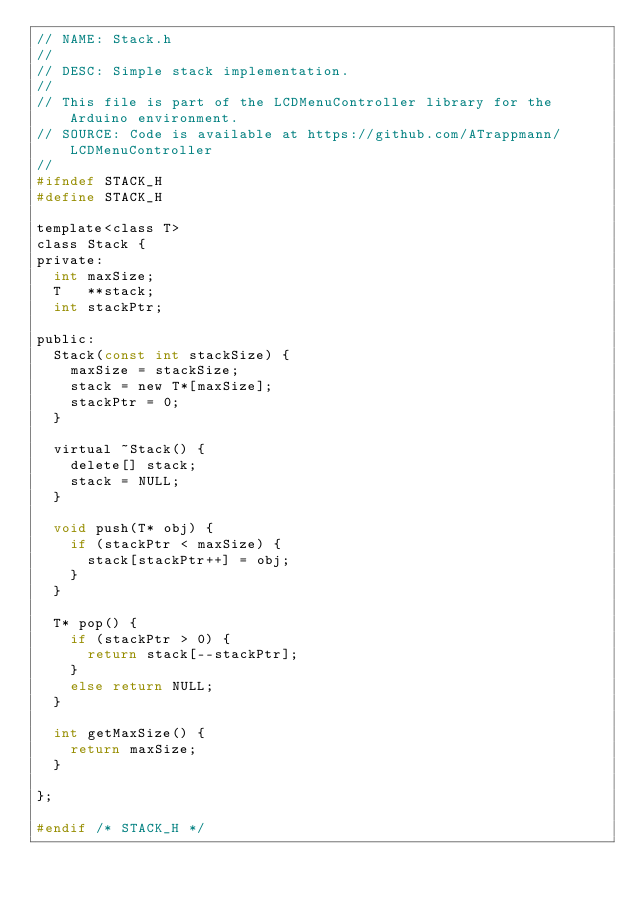Convert code to text. <code><loc_0><loc_0><loc_500><loc_500><_C_>// NAME: Stack.h
// 
// DESC: Simple stack implementation.
//
// This file is part of the LCDMenuController library for the Arduino environment.
// SOURCE: Code is available at https://github.com/ATrappmann/LCDMenuController
//
#ifndef STACK_H
#define STACK_H

template<class T>
class Stack {
private:
  int maxSize;
  T   **stack;
  int stackPtr;
  
public:
  Stack(const int stackSize) {
    maxSize = stackSize;
    stack = new T*[maxSize];
    stackPtr = 0;
  }
  
  virtual ~Stack() {
    delete[] stack;
    stack = NULL;
  }

  void push(T* obj) {
    if (stackPtr < maxSize) {
      stack[stackPtr++] = obj;
    }
  }
  
  T* pop() { 
    if (stackPtr > 0) {
      return stack[--stackPtr];      
    }
    else return NULL;
  }

  int getMaxSize() {
    return maxSize;
  }
  
};

#endif /* STACK_H */
</code> 